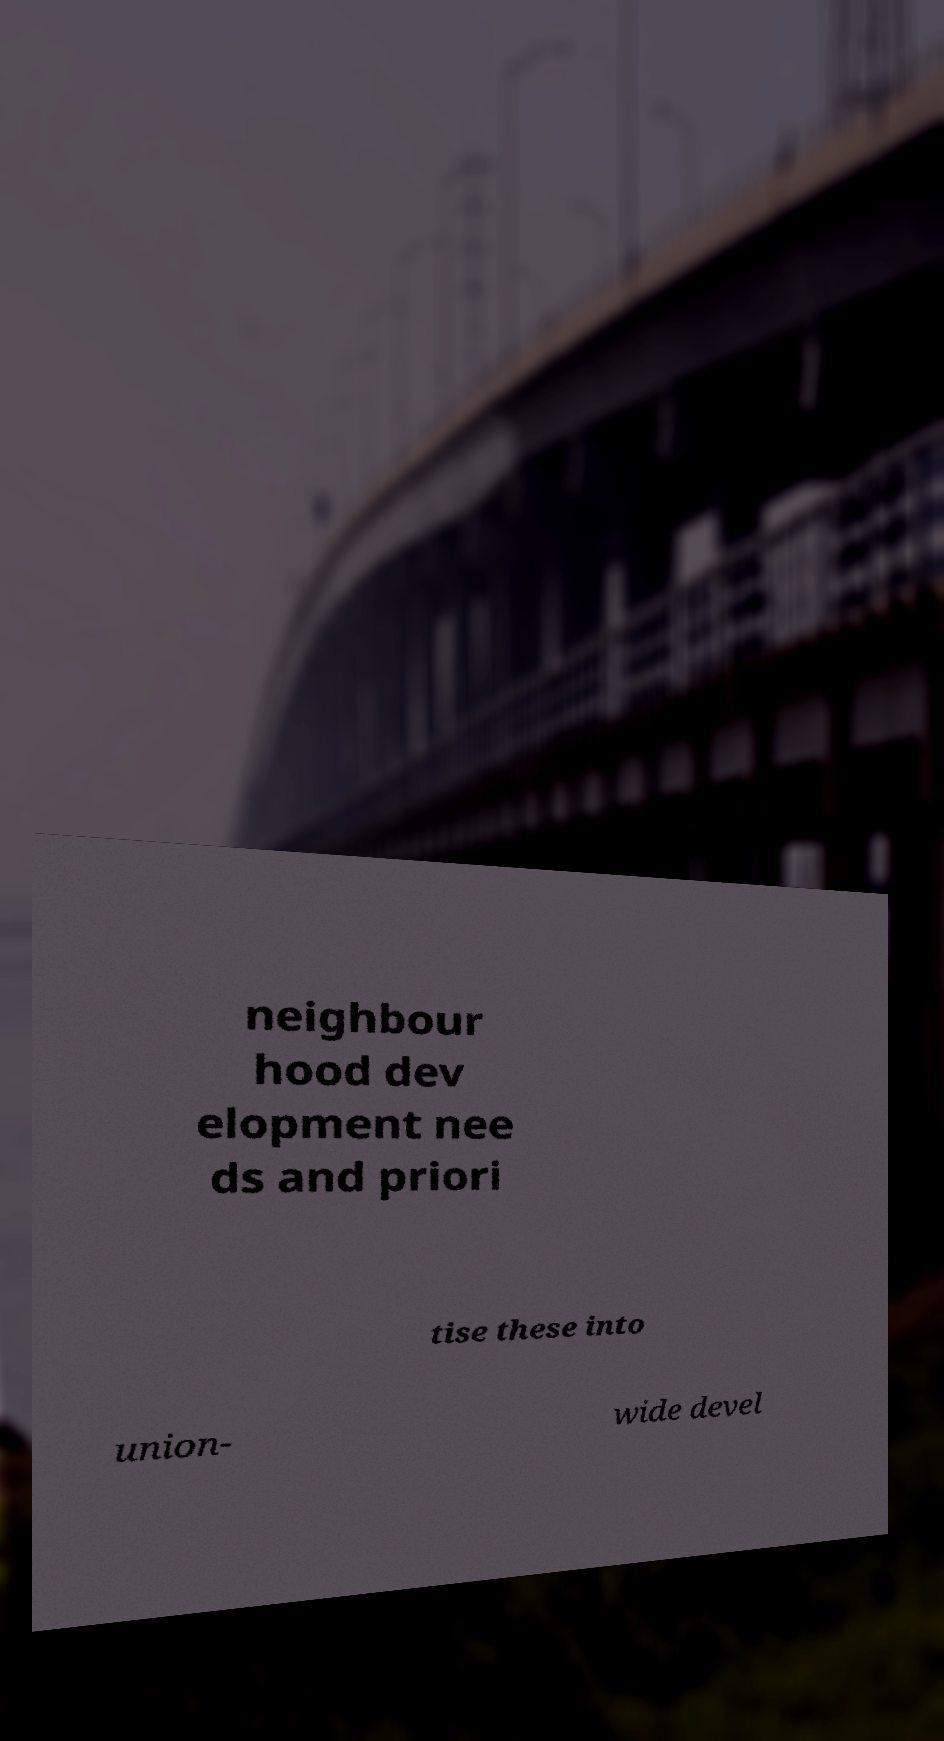Could you extract and type out the text from this image? neighbour hood dev elopment nee ds and priori tise these into union- wide devel 